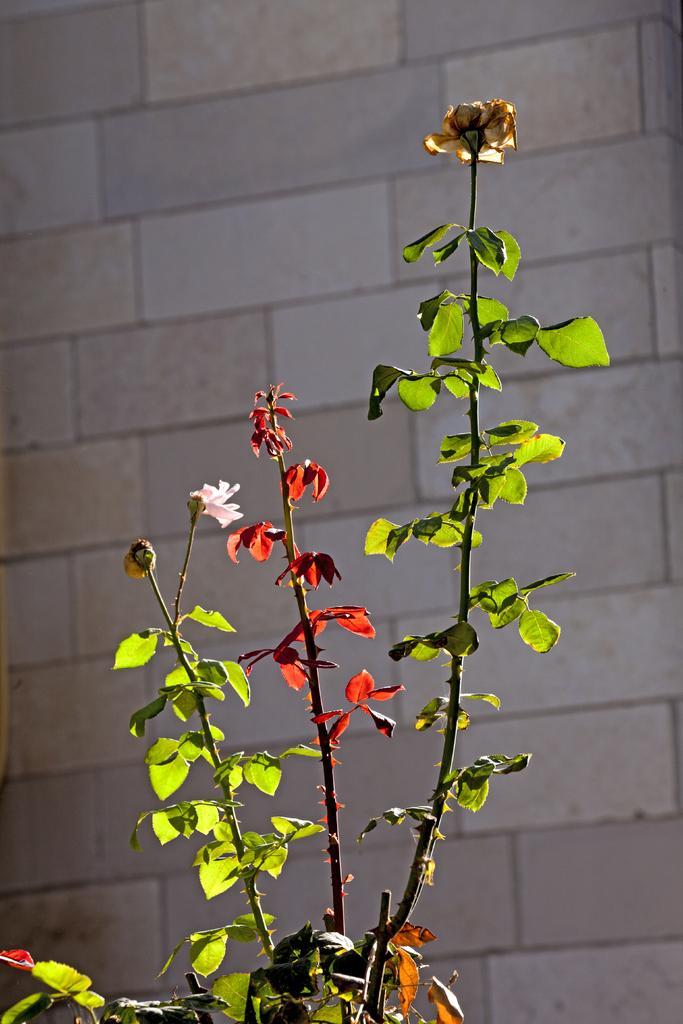How would you summarize this image in a sentence or two? In this image I can see green and red colour leaves. I can also see few flowers and in the background I can see a wall. 